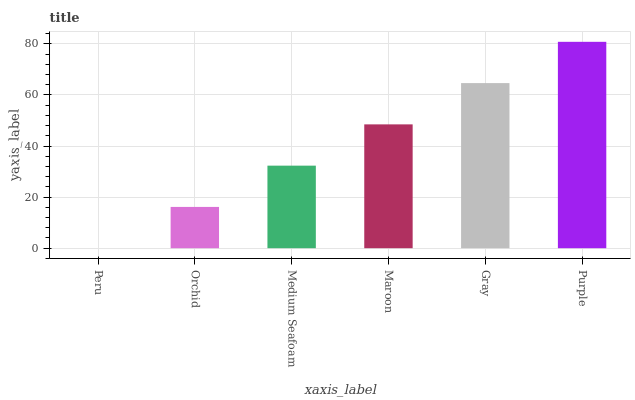Is Peru the minimum?
Answer yes or no. Yes. Is Purple the maximum?
Answer yes or no. Yes. Is Orchid the minimum?
Answer yes or no. No. Is Orchid the maximum?
Answer yes or no. No. Is Orchid greater than Peru?
Answer yes or no. Yes. Is Peru less than Orchid?
Answer yes or no. Yes. Is Peru greater than Orchid?
Answer yes or no. No. Is Orchid less than Peru?
Answer yes or no. No. Is Maroon the high median?
Answer yes or no. Yes. Is Medium Seafoam the low median?
Answer yes or no. Yes. Is Gray the high median?
Answer yes or no. No. Is Maroon the low median?
Answer yes or no. No. 